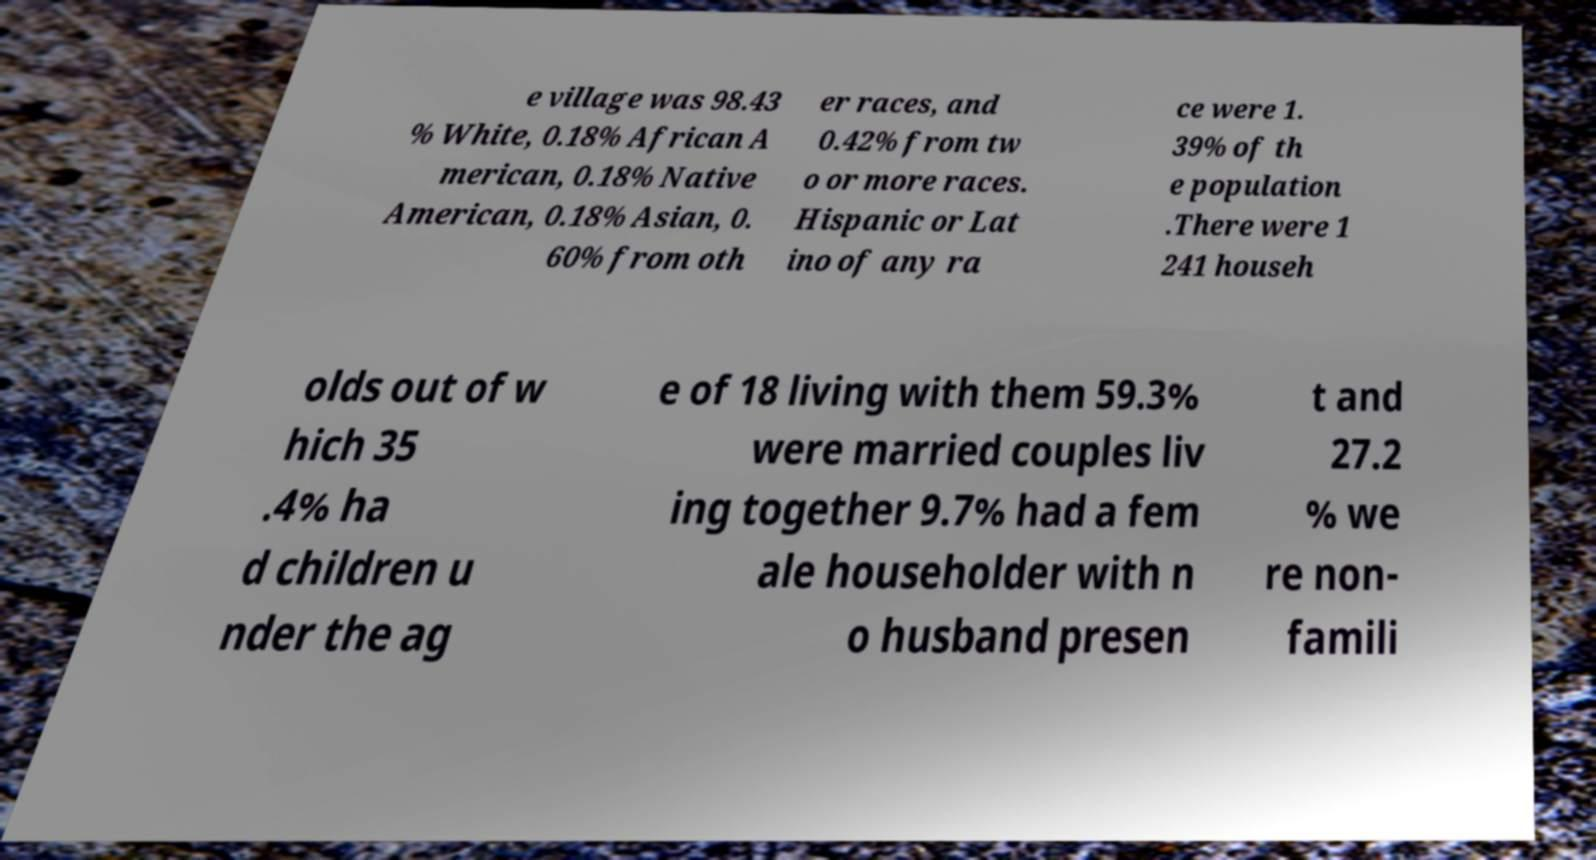Can you accurately transcribe the text from the provided image for me? e village was 98.43 % White, 0.18% African A merican, 0.18% Native American, 0.18% Asian, 0. 60% from oth er races, and 0.42% from tw o or more races. Hispanic or Lat ino of any ra ce were 1. 39% of th e population .There were 1 241 househ olds out of w hich 35 .4% ha d children u nder the ag e of 18 living with them 59.3% were married couples liv ing together 9.7% had a fem ale householder with n o husband presen t and 27.2 % we re non- famili 